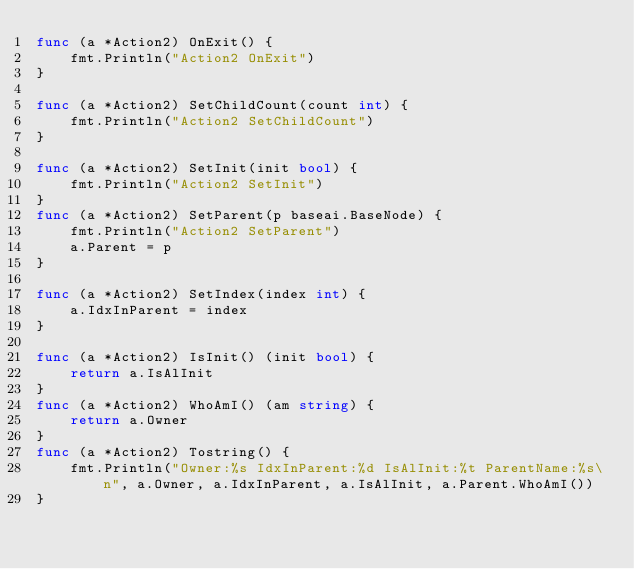Convert code to text. <code><loc_0><loc_0><loc_500><loc_500><_Go_>func (a *Action2) OnExit() {
	fmt.Println("Action2 OnExit")
}

func (a *Action2) SetChildCount(count int) {
	fmt.Println("Action2 SetChildCount")
}

func (a *Action2) SetInit(init bool) {
	fmt.Println("Action2 SetInit")
}
func (a *Action2) SetParent(p baseai.BaseNode) {
	fmt.Println("Action2 SetParent")
	a.Parent = p
}

func (a *Action2) SetIndex(index int) {
	a.IdxInParent = index
}

func (a *Action2) IsInit() (init bool) {
	return a.IsAlInit
}
func (a *Action2) WhoAmI() (am string) {
	return a.Owner
}
func (a *Action2) Tostring() {
	fmt.Println("Owner:%s IdxInParent:%d IsAlInit:%t ParentName:%s\n", a.Owner, a.IdxInParent, a.IsAlInit, a.Parent.WhoAmI())
}
</code> 